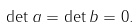Convert formula to latex. <formula><loc_0><loc_0><loc_500><loc_500>\det a = \det b = 0 .</formula> 